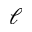Convert formula to latex. <formula><loc_0><loc_0><loc_500><loc_500>\ell</formula> 